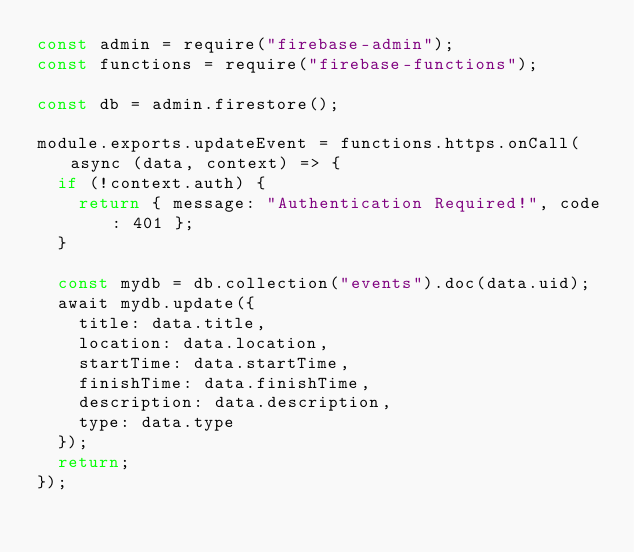Convert code to text. <code><loc_0><loc_0><loc_500><loc_500><_JavaScript_>const admin = require("firebase-admin");
const functions = require("firebase-functions");

const db = admin.firestore();

module.exports.updateEvent = functions.https.onCall(async (data, context) => {
  if (!context.auth) {
    return { message: "Authentication Required!", code: 401 };
  }

  const mydb = db.collection("events").doc(data.uid);
  await mydb.update({
    title: data.title,
    location: data.location,
    startTime: data.startTime,
    finishTime: data.finishTime,
    description: data.description,
    type: data.type
  });
  return;
});
</code> 